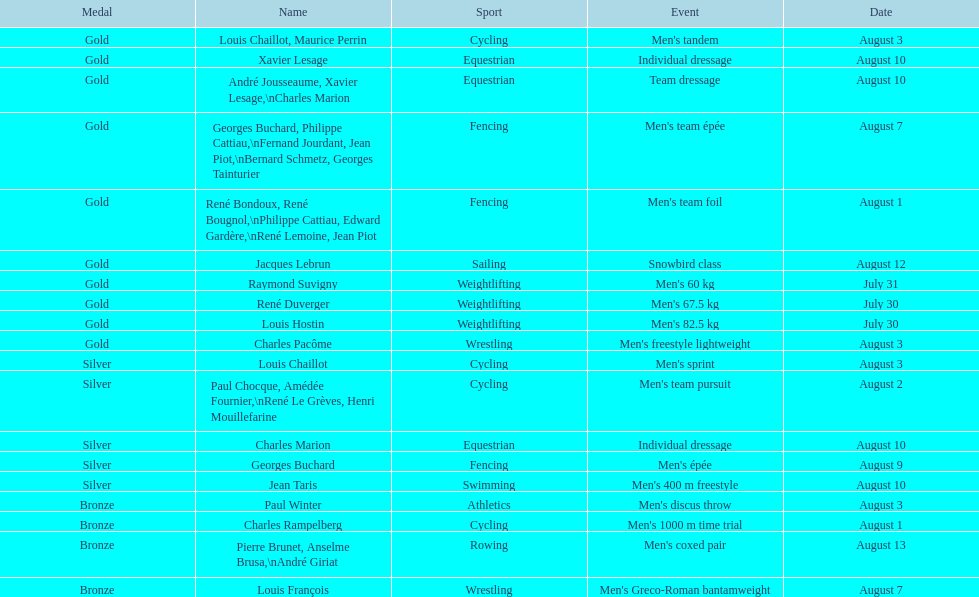In the list, which sport comes first? Cycling. 